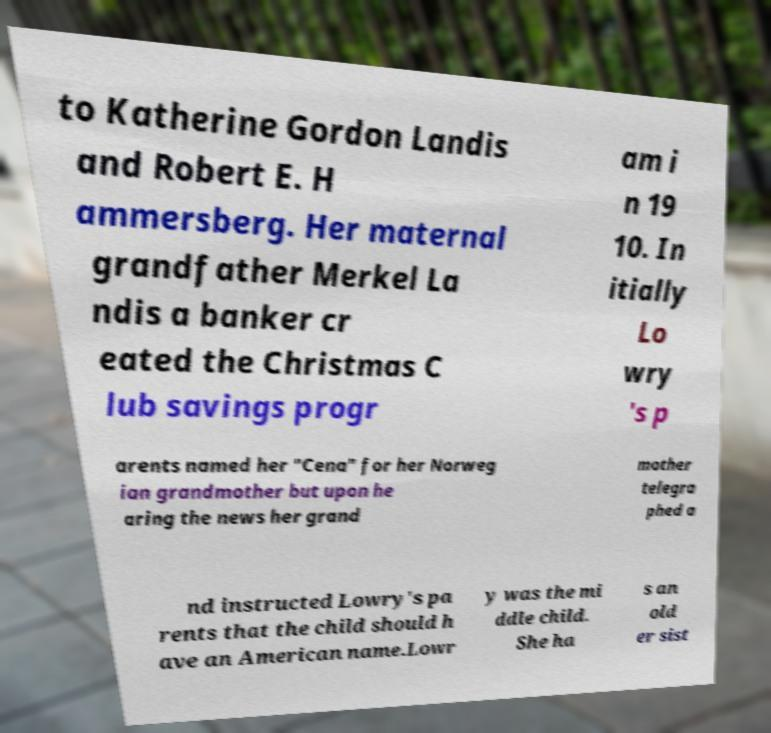What messages or text are displayed in this image? I need them in a readable, typed format. to Katherine Gordon Landis and Robert E. H ammersberg. Her maternal grandfather Merkel La ndis a banker cr eated the Christmas C lub savings progr am i n 19 10. In itially Lo wry 's p arents named her "Cena" for her Norweg ian grandmother but upon he aring the news her grand mother telegra phed a nd instructed Lowry's pa rents that the child should h ave an American name.Lowr y was the mi ddle child. She ha s an old er sist 